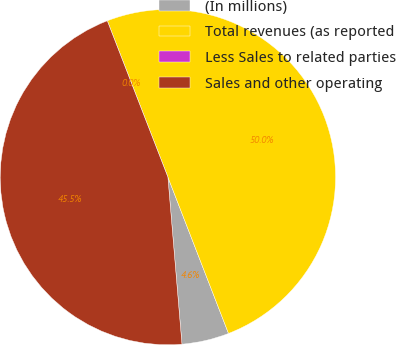Convert chart to OTSL. <chart><loc_0><loc_0><loc_500><loc_500><pie_chart><fcel>(In millions)<fcel>Total revenues (as reported<fcel>Less Sales to related parties<fcel>Sales and other operating<nl><fcel>4.55%<fcel>50.0%<fcel>0.0%<fcel>45.45%<nl></chart> 